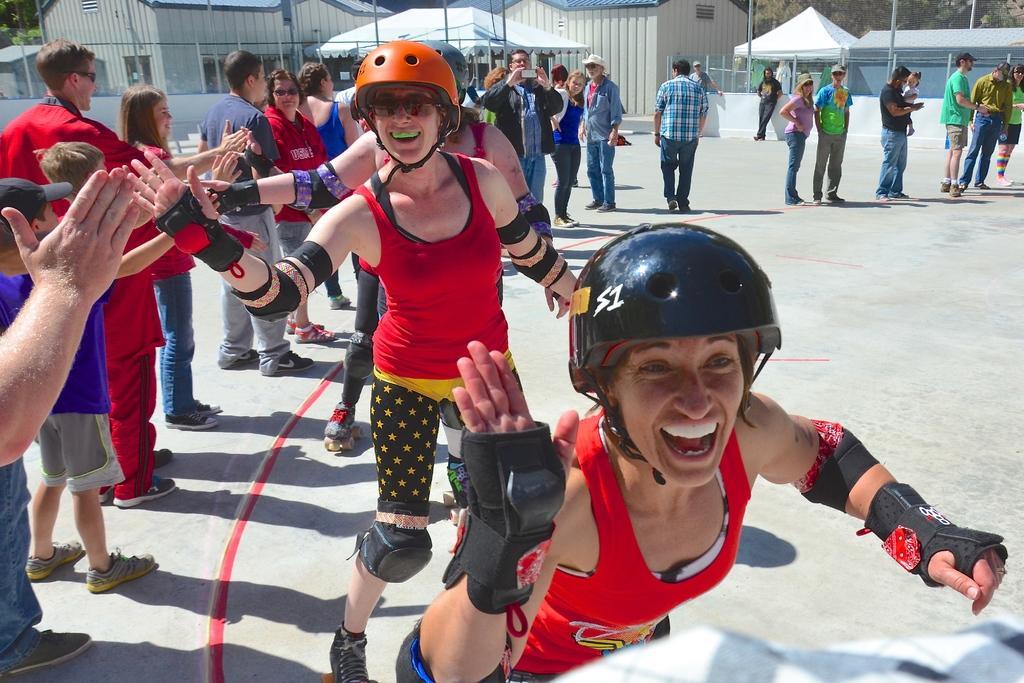How would you summarize this image in a sentence or two? In this image I can see three beautiful women are doing the skating, they wore red color tops, black color shorts also smiling. On the left side a group of people are standing, at the back side there are sheds. 